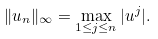Convert formula to latex. <formula><loc_0><loc_0><loc_500><loc_500>\| u _ { n } \| _ { \infty } = \max _ { 1 \leq j \leq n } | u ^ { j } | .</formula> 